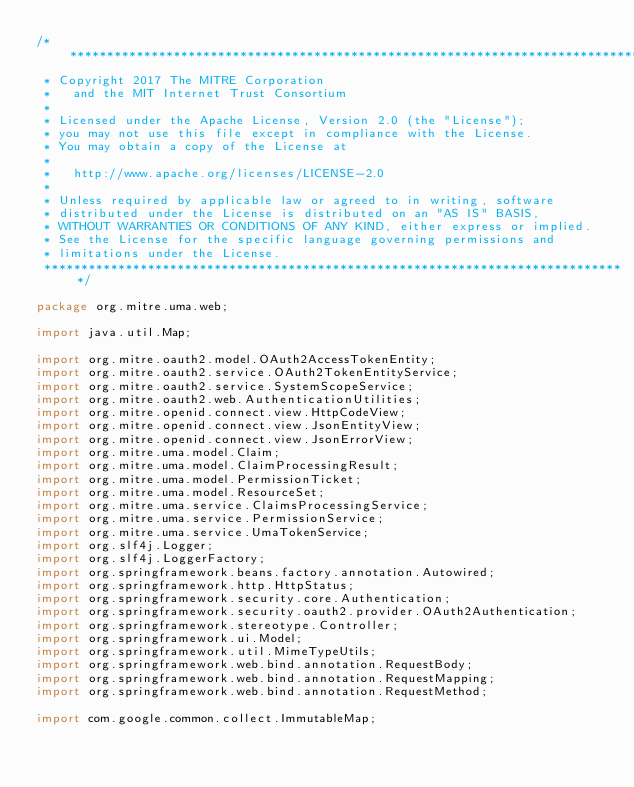Convert code to text. <code><loc_0><loc_0><loc_500><loc_500><_Java_>/*******************************************************************************
 * Copyright 2017 The MITRE Corporation
 *   and the MIT Internet Trust Consortium
 *
 * Licensed under the Apache License, Version 2.0 (the "License");
 * you may not use this file except in compliance with the License.
 * You may obtain a copy of the License at
 *
 *   http://www.apache.org/licenses/LICENSE-2.0
 *
 * Unless required by applicable law or agreed to in writing, software
 * distributed under the License is distributed on an "AS IS" BASIS,
 * WITHOUT WARRANTIES OR CONDITIONS OF ANY KIND, either express or implied.
 * See the License for the specific language governing permissions and
 * limitations under the License.
 *******************************************************************************/

package org.mitre.uma.web;

import java.util.Map;

import org.mitre.oauth2.model.OAuth2AccessTokenEntity;
import org.mitre.oauth2.service.OAuth2TokenEntityService;
import org.mitre.oauth2.service.SystemScopeService;
import org.mitre.oauth2.web.AuthenticationUtilities;
import org.mitre.openid.connect.view.HttpCodeView;
import org.mitre.openid.connect.view.JsonEntityView;
import org.mitre.openid.connect.view.JsonErrorView;
import org.mitre.uma.model.Claim;
import org.mitre.uma.model.ClaimProcessingResult;
import org.mitre.uma.model.PermissionTicket;
import org.mitre.uma.model.ResourceSet;
import org.mitre.uma.service.ClaimsProcessingService;
import org.mitre.uma.service.PermissionService;
import org.mitre.uma.service.UmaTokenService;
import org.slf4j.Logger;
import org.slf4j.LoggerFactory;
import org.springframework.beans.factory.annotation.Autowired;
import org.springframework.http.HttpStatus;
import org.springframework.security.core.Authentication;
import org.springframework.security.oauth2.provider.OAuth2Authentication;
import org.springframework.stereotype.Controller;
import org.springframework.ui.Model;
import org.springframework.util.MimeTypeUtils;
import org.springframework.web.bind.annotation.RequestBody;
import org.springframework.web.bind.annotation.RequestMapping;
import org.springframework.web.bind.annotation.RequestMethod;

import com.google.common.collect.ImmutableMap;</code> 